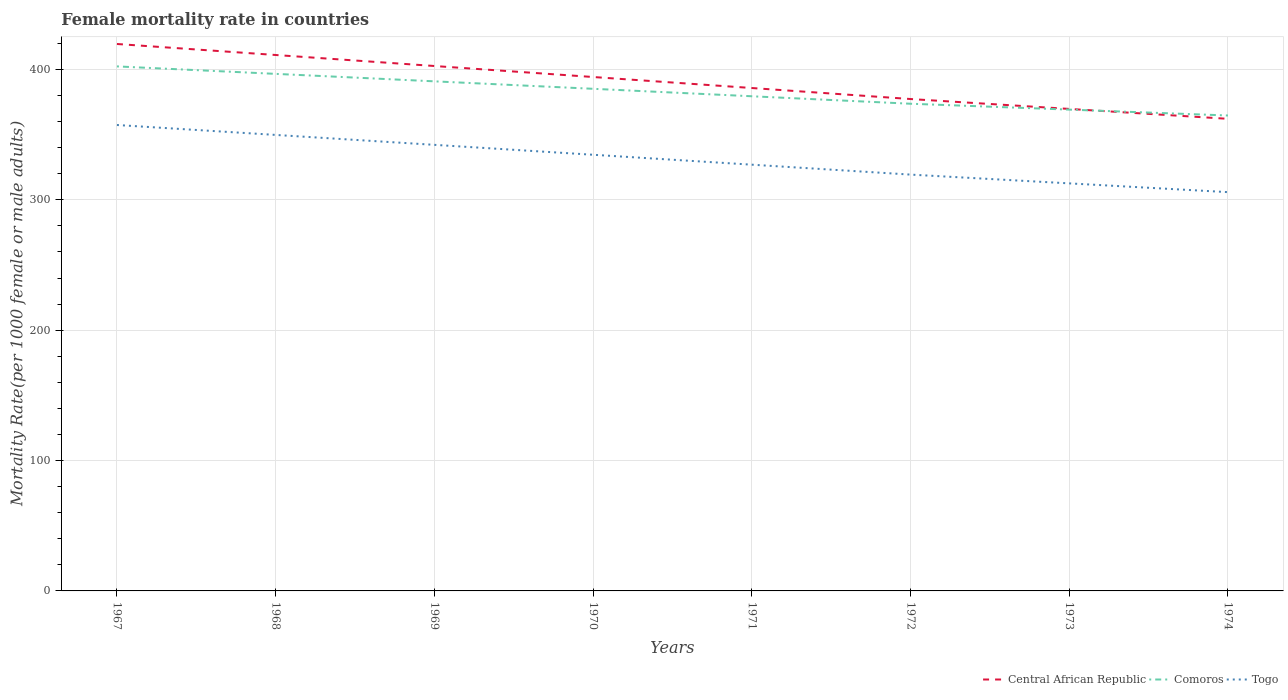How many different coloured lines are there?
Ensure brevity in your answer.  3. Does the line corresponding to Togo intersect with the line corresponding to Central African Republic?
Provide a short and direct response. No. Is the number of lines equal to the number of legend labels?
Your answer should be compact. Yes. Across all years, what is the maximum female mortality rate in Togo?
Make the answer very short. 305.9. In which year was the female mortality rate in Comoros maximum?
Your answer should be very brief. 1974. What is the total female mortality rate in Central African Republic in the graph?
Offer a terse response. 41.37. What is the difference between the highest and the second highest female mortality rate in Central African Republic?
Keep it short and to the point. 57.41. How many years are there in the graph?
Keep it short and to the point. 8. What is the difference between two consecutive major ticks on the Y-axis?
Make the answer very short. 100. Does the graph contain any zero values?
Give a very brief answer. No. Where does the legend appear in the graph?
Offer a very short reply. Bottom right. How many legend labels are there?
Ensure brevity in your answer.  3. What is the title of the graph?
Give a very brief answer. Female mortality rate in countries. Does "Tonga" appear as one of the legend labels in the graph?
Provide a succinct answer. No. What is the label or title of the X-axis?
Offer a very short reply. Years. What is the label or title of the Y-axis?
Your response must be concise. Mortality Rate(per 1000 female or male adults). What is the Mortality Rate(per 1000 female or male adults) of Central African Republic in 1967?
Your answer should be very brief. 419.55. What is the Mortality Rate(per 1000 female or male adults) of Comoros in 1967?
Ensure brevity in your answer.  402.36. What is the Mortality Rate(per 1000 female or male adults) of Togo in 1967?
Provide a short and direct response. 357.4. What is the Mortality Rate(per 1000 female or male adults) in Central African Republic in 1968?
Make the answer very short. 411.11. What is the Mortality Rate(per 1000 female or male adults) in Comoros in 1968?
Your answer should be compact. 396.63. What is the Mortality Rate(per 1000 female or male adults) of Togo in 1968?
Give a very brief answer. 349.79. What is the Mortality Rate(per 1000 female or male adults) in Central African Republic in 1969?
Give a very brief answer. 402.66. What is the Mortality Rate(per 1000 female or male adults) in Comoros in 1969?
Your response must be concise. 390.9. What is the Mortality Rate(per 1000 female or male adults) in Togo in 1969?
Your answer should be compact. 342.18. What is the Mortality Rate(per 1000 female or male adults) of Central African Republic in 1970?
Your answer should be compact. 394.22. What is the Mortality Rate(per 1000 female or male adults) of Comoros in 1970?
Your answer should be very brief. 385.17. What is the Mortality Rate(per 1000 female or male adults) in Togo in 1970?
Provide a succinct answer. 334.57. What is the Mortality Rate(per 1000 female or male adults) in Central African Republic in 1971?
Offer a very short reply. 385.77. What is the Mortality Rate(per 1000 female or male adults) of Comoros in 1971?
Give a very brief answer. 379.44. What is the Mortality Rate(per 1000 female or male adults) of Togo in 1971?
Make the answer very short. 326.97. What is the Mortality Rate(per 1000 female or male adults) of Central African Republic in 1972?
Offer a very short reply. 377.33. What is the Mortality Rate(per 1000 female or male adults) in Comoros in 1972?
Your answer should be compact. 373.72. What is the Mortality Rate(per 1000 female or male adults) of Togo in 1972?
Your response must be concise. 319.36. What is the Mortality Rate(per 1000 female or male adults) in Central African Republic in 1973?
Provide a short and direct response. 369.74. What is the Mortality Rate(per 1000 female or male adults) in Comoros in 1973?
Offer a very short reply. 369.21. What is the Mortality Rate(per 1000 female or male adults) in Togo in 1973?
Provide a succinct answer. 312.63. What is the Mortality Rate(per 1000 female or male adults) of Central African Republic in 1974?
Your answer should be very brief. 362.14. What is the Mortality Rate(per 1000 female or male adults) of Comoros in 1974?
Provide a succinct answer. 364.7. What is the Mortality Rate(per 1000 female or male adults) of Togo in 1974?
Provide a succinct answer. 305.9. Across all years, what is the maximum Mortality Rate(per 1000 female or male adults) in Central African Republic?
Make the answer very short. 419.55. Across all years, what is the maximum Mortality Rate(per 1000 female or male adults) of Comoros?
Keep it short and to the point. 402.36. Across all years, what is the maximum Mortality Rate(per 1000 female or male adults) of Togo?
Provide a succinct answer. 357.4. Across all years, what is the minimum Mortality Rate(per 1000 female or male adults) in Central African Republic?
Ensure brevity in your answer.  362.14. Across all years, what is the minimum Mortality Rate(per 1000 female or male adults) of Comoros?
Ensure brevity in your answer.  364.7. Across all years, what is the minimum Mortality Rate(per 1000 female or male adults) of Togo?
Ensure brevity in your answer.  305.9. What is the total Mortality Rate(per 1000 female or male adults) in Central African Republic in the graph?
Provide a short and direct response. 3122.51. What is the total Mortality Rate(per 1000 female or male adults) of Comoros in the graph?
Your response must be concise. 3062.12. What is the total Mortality Rate(per 1000 female or male adults) of Togo in the graph?
Make the answer very short. 2648.8. What is the difference between the Mortality Rate(per 1000 female or male adults) in Central African Republic in 1967 and that in 1968?
Offer a very short reply. 8.45. What is the difference between the Mortality Rate(per 1000 female or male adults) of Comoros in 1967 and that in 1968?
Your answer should be very brief. 5.73. What is the difference between the Mortality Rate(per 1000 female or male adults) in Togo in 1967 and that in 1968?
Offer a terse response. 7.61. What is the difference between the Mortality Rate(per 1000 female or male adults) of Central African Republic in 1967 and that in 1969?
Keep it short and to the point. 16.89. What is the difference between the Mortality Rate(per 1000 female or male adults) in Comoros in 1967 and that in 1969?
Keep it short and to the point. 11.46. What is the difference between the Mortality Rate(per 1000 female or male adults) in Togo in 1967 and that in 1969?
Provide a short and direct response. 15.22. What is the difference between the Mortality Rate(per 1000 female or male adults) of Central African Republic in 1967 and that in 1970?
Your answer should be compact. 25.33. What is the difference between the Mortality Rate(per 1000 female or male adults) in Comoros in 1967 and that in 1970?
Your answer should be compact. 17.18. What is the difference between the Mortality Rate(per 1000 female or male adults) in Togo in 1967 and that in 1970?
Your answer should be very brief. 22.83. What is the difference between the Mortality Rate(per 1000 female or male adults) in Central African Republic in 1967 and that in 1971?
Provide a succinct answer. 33.78. What is the difference between the Mortality Rate(per 1000 female or male adults) of Comoros in 1967 and that in 1971?
Provide a short and direct response. 22.91. What is the difference between the Mortality Rate(per 1000 female or male adults) in Togo in 1967 and that in 1971?
Keep it short and to the point. 30.43. What is the difference between the Mortality Rate(per 1000 female or male adults) in Central African Republic in 1967 and that in 1972?
Ensure brevity in your answer.  42.22. What is the difference between the Mortality Rate(per 1000 female or male adults) in Comoros in 1967 and that in 1972?
Your answer should be compact. 28.64. What is the difference between the Mortality Rate(per 1000 female or male adults) in Togo in 1967 and that in 1972?
Your response must be concise. 38.04. What is the difference between the Mortality Rate(per 1000 female or male adults) in Central African Republic in 1967 and that in 1973?
Provide a short and direct response. 49.82. What is the difference between the Mortality Rate(per 1000 female or male adults) in Comoros in 1967 and that in 1973?
Your answer should be compact. 33.15. What is the difference between the Mortality Rate(per 1000 female or male adults) of Togo in 1967 and that in 1973?
Your answer should be compact. 44.77. What is the difference between the Mortality Rate(per 1000 female or male adults) of Central African Republic in 1967 and that in 1974?
Provide a short and direct response. 57.41. What is the difference between the Mortality Rate(per 1000 female or male adults) of Comoros in 1967 and that in 1974?
Provide a succinct answer. 37.66. What is the difference between the Mortality Rate(per 1000 female or male adults) of Togo in 1967 and that in 1974?
Give a very brief answer. 51.5. What is the difference between the Mortality Rate(per 1000 female or male adults) in Central African Republic in 1968 and that in 1969?
Make the answer very short. 8.45. What is the difference between the Mortality Rate(per 1000 female or male adults) in Comoros in 1968 and that in 1969?
Make the answer very short. 5.73. What is the difference between the Mortality Rate(per 1000 female or male adults) of Togo in 1968 and that in 1969?
Provide a short and direct response. 7.61. What is the difference between the Mortality Rate(per 1000 female or male adults) of Central African Republic in 1968 and that in 1970?
Provide a short and direct response. 16.89. What is the difference between the Mortality Rate(per 1000 female or male adults) of Comoros in 1968 and that in 1970?
Keep it short and to the point. 11.46. What is the difference between the Mortality Rate(per 1000 female or male adults) in Togo in 1968 and that in 1970?
Provide a short and direct response. 15.22. What is the difference between the Mortality Rate(per 1000 female or male adults) of Central African Republic in 1968 and that in 1971?
Your response must be concise. 25.33. What is the difference between the Mortality Rate(per 1000 female or male adults) in Comoros in 1968 and that in 1971?
Your response must be concise. 17.18. What is the difference between the Mortality Rate(per 1000 female or male adults) of Togo in 1968 and that in 1971?
Give a very brief answer. 22.83. What is the difference between the Mortality Rate(per 1000 female or male adults) in Central African Republic in 1968 and that in 1972?
Provide a succinct answer. 33.78. What is the difference between the Mortality Rate(per 1000 female or male adults) in Comoros in 1968 and that in 1972?
Offer a terse response. 22.91. What is the difference between the Mortality Rate(per 1000 female or male adults) of Togo in 1968 and that in 1972?
Provide a succinct answer. 30.43. What is the difference between the Mortality Rate(per 1000 female or male adults) of Central African Republic in 1968 and that in 1973?
Ensure brevity in your answer.  41.37. What is the difference between the Mortality Rate(per 1000 female or male adults) in Comoros in 1968 and that in 1973?
Provide a succinct answer. 27.42. What is the difference between the Mortality Rate(per 1000 female or male adults) in Togo in 1968 and that in 1973?
Your answer should be very brief. 37.16. What is the difference between the Mortality Rate(per 1000 female or male adults) in Central African Republic in 1968 and that in 1974?
Your answer should be compact. 48.96. What is the difference between the Mortality Rate(per 1000 female or male adults) of Comoros in 1968 and that in 1974?
Keep it short and to the point. 31.93. What is the difference between the Mortality Rate(per 1000 female or male adults) of Togo in 1968 and that in 1974?
Provide a succinct answer. 43.89. What is the difference between the Mortality Rate(per 1000 female or male adults) of Central African Republic in 1969 and that in 1970?
Offer a terse response. 8.44. What is the difference between the Mortality Rate(per 1000 female or male adults) in Comoros in 1969 and that in 1970?
Offer a terse response. 5.73. What is the difference between the Mortality Rate(per 1000 female or male adults) in Togo in 1969 and that in 1970?
Provide a succinct answer. 7.61. What is the difference between the Mortality Rate(per 1000 female or male adults) of Central African Republic in 1969 and that in 1971?
Your answer should be compact. 16.89. What is the difference between the Mortality Rate(per 1000 female or male adults) of Comoros in 1969 and that in 1971?
Give a very brief answer. 11.46. What is the difference between the Mortality Rate(per 1000 female or male adults) in Togo in 1969 and that in 1971?
Keep it short and to the point. 15.22. What is the difference between the Mortality Rate(per 1000 female or male adults) of Central African Republic in 1969 and that in 1972?
Make the answer very short. 25.33. What is the difference between the Mortality Rate(per 1000 female or male adults) of Comoros in 1969 and that in 1972?
Your answer should be compact. 17.18. What is the difference between the Mortality Rate(per 1000 female or male adults) in Togo in 1969 and that in 1972?
Provide a succinct answer. 22.83. What is the difference between the Mortality Rate(per 1000 female or male adults) in Central African Republic in 1969 and that in 1973?
Your answer should be compact. 32.93. What is the difference between the Mortality Rate(per 1000 female or male adults) of Comoros in 1969 and that in 1973?
Keep it short and to the point. 21.7. What is the difference between the Mortality Rate(per 1000 female or male adults) of Togo in 1969 and that in 1973?
Your answer should be compact. 29.55. What is the difference between the Mortality Rate(per 1000 female or male adults) of Central African Republic in 1969 and that in 1974?
Your answer should be compact. 40.52. What is the difference between the Mortality Rate(per 1000 female or male adults) of Comoros in 1969 and that in 1974?
Keep it short and to the point. 26.2. What is the difference between the Mortality Rate(per 1000 female or male adults) in Togo in 1969 and that in 1974?
Your response must be concise. 36.28. What is the difference between the Mortality Rate(per 1000 female or male adults) in Central African Republic in 1970 and that in 1971?
Keep it short and to the point. 8.45. What is the difference between the Mortality Rate(per 1000 female or male adults) of Comoros in 1970 and that in 1971?
Keep it short and to the point. 5.73. What is the difference between the Mortality Rate(per 1000 female or male adults) of Togo in 1970 and that in 1971?
Make the answer very short. 7.61. What is the difference between the Mortality Rate(per 1000 female or male adults) in Central African Republic in 1970 and that in 1972?
Offer a terse response. 16.89. What is the difference between the Mortality Rate(per 1000 female or male adults) of Comoros in 1970 and that in 1972?
Ensure brevity in your answer.  11.46. What is the difference between the Mortality Rate(per 1000 female or male adults) in Togo in 1970 and that in 1972?
Provide a short and direct response. 15.22. What is the difference between the Mortality Rate(per 1000 female or male adults) in Central African Republic in 1970 and that in 1973?
Ensure brevity in your answer.  24.48. What is the difference between the Mortality Rate(per 1000 female or male adults) in Comoros in 1970 and that in 1973?
Your answer should be very brief. 15.97. What is the difference between the Mortality Rate(per 1000 female or male adults) in Togo in 1970 and that in 1973?
Your answer should be compact. 21.95. What is the difference between the Mortality Rate(per 1000 female or male adults) in Central African Republic in 1970 and that in 1974?
Your answer should be compact. 32.07. What is the difference between the Mortality Rate(per 1000 female or male adults) in Comoros in 1970 and that in 1974?
Your response must be concise. 20.48. What is the difference between the Mortality Rate(per 1000 female or male adults) of Togo in 1970 and that in 1974?
Your answer should be compact. 28.67. What is the difference between the Mortality Rate(per 1000 female or male adults) of Central African Republic in 1971 and that in 1972?
Your answer should be very brief. 8.45. What is the difference between the Mortality Rate(per 1000 female or male adults) in Comoros in 1971 and that in 1972?
Keep it short and to the point. 5.73. What is the difference between the Mortality Rate(per 1000 female or male adults) in Togo in 1971 and that in 1972?
Offer a very short reply. 7.61. What is the difference between the Mortality Rate(per 1000 female or male adults) in Central African Republic in 1971 and that in 1973?
Ensure brevity in your answer.  16.04. What is the difference between the Mortality Rate(per 1000 female or male adults) of Comoros in 1971 and that in 1973?
Ensure brevity in your answer.  10.24. What is the difference between the Mortality Rate(per 1000 female or male adults) of Togo in 1971 and that in 1973?
Offer a very short reply. 14.34. What is the difference between the Mortality Rate(per 1000 female or male adults) in Central African Republic in 1971 and that in 1974?
Keep it short and to the point. 23.63. What is the difference between the Mortality Rate(per 1000 female or male adults) of Comoros in 1971 and that in 1974?
Give a very brief answer. 14.75. What is the difference between the Mortality Rate(per 1000 female or male adults) in Togo in 1971 and that in 1974?
Offer a very short reply. 21.07. What is the difference between the Mortality Rate(per 1000 female or male adults) of Central African Republic in 1972 and that in 1973?
Your response must be concise. 7.59. What is the difference between the Mortality Rate(per 1000 female or male adults) in Comoros in 1972 and that in 1973?
Keep it short and to the point. 4.51. What is the difference between the Mortality Rate(per 1000 female or male adults) in Togo in 1972 and that in 1973?
Make the answer very short. 6.73. What is the difference between the Mortality Rate(per 1000 female or male adults) in Central African Republic in 1972 and that in 1974?
Provide a succinct answer. 15.18. What is the difference between the Mortality Rate(per 1000 female or male adults) of Comoros in 1972 and that in 1974?
Provide a succinct answer. 9.02. What is the difference between the Mortality Rate(per 1000 female or male adults) in Togo in 1972 and that in 1974?
Offer a terse response. 13.46. What is the difference between the Mortality Rate(per 1000 female or male adults) in Central African Republic in 1973 and that in 1974?
Your answer should be very brief. 7.59. What is the difference between the Mortality Rate(per 1000 female or male adults) of Comoros in 1973 and that in 1974?
Keep it short and to the point. 4.51. What is the difference between the Mortality Rate(per 1000 female or male adults) of Togo in 1973 and that in 1974?
Your answer should be compact. 6.73. What is the difference between the Mortality Rate(per 1000 female or male adults) in Central African Republic in 1967 and the Mortality Rate(per 1000 female or male adults) in Comoros in 1968?
Keep it short and to the point. 22.92. What is the difference between the Mortality Rate(per 1000 female or male adults) of Central African Republic in 1967 and the Mortality Rate(per 1000 female or male adults) of Togo in 1968?
Provide a succinct answer. 69.76. What is the difference between the Mortality Rate(per 1000 female or male adults) of Comoros in 1967 and the Mortality Rate(per 1000 female or male adults) of Togo in 1968?
Provide a short and direct response. 52.57. What is the difference between the Mortality Rate(per 1000 female or male adults) in Central African Republic in 1967 and the Mortality Rate(per 1000 female or male adults) in Comoros in 1969?
Ensure brevity in your answer.  28.65. What is the difference between the Mortality Rate(per 1000 female or male adults) in Central African Republic in 1967 and the Mortality Rate(per 1000 female or male adults) in Togo in 1969?
Give a very brief answer. 77.37. What is the difference between the Mortality Rate(per 1000 female or male adults) of Comoros in 1967 and the Mortality Rate(per 1000 female or male adults) of Togo in 1969?
Ensure brevity in your answer.  60.17. What is the difference between the Mortality Rate(per 1000 female or male adults) of Central African Republic in 1967 and the Mortality Rate(per 1000 female or male adults) of Comoros in 1970?
Provide a short and direct response. 34.38. What is the difference between the Mortality Rate(per 1000 female or male adults) in Central African Republic in 1967 and the Mortality Rate(per 1000 female or male adults) in Togo in 1970?
Make the answer very short. 84.98. What is the difference between the Mortality Rate(per 1000 female or male adults) of Comoros in 1967 and the Mortality Rate(per 1000 female or male adults) of Togo in 1970?
Your answer should be very brief. 67.78. What is the difference between the Mortality Rate(per 1000 female or male adults) in Central African Republic in 1967 and the Mortality Rate(per 1000 female or male adults) in Comoros in 1971?
Make the answer very short. 40.11. What is the difference between the Mortality Rate(per 1000 female or male adults) of Central African Republic in 1967 and the Mortality Rate(per 1000 female or male adults) of Togo in 1971?
Your answer should be compact. 92.58. What is the difference between the Mortality Rate(per 1000 female or male adults) in Comoros in 1967 and the Mortality Rate(per 1000 female or male adults) in Togo in 1971?
Provide a short and direct response. 75.39. What is the difference between the Mortality Rate(per 1000 female or male adults) in Central African Republic in 1967 and the Mortality Rate(per 1000 female or male adults) in Comoros in 1972?
Keep it short and to the point. 45.84. What is the difference between the Mortality Rate(per 1000 female or male adults) of Central African Republic in 1967 and the Mortality Rate(per 1000 female or male adults) of Togo in 1972?
Your answer should be compact. 100.19. What is the difference between the Mortality Rate(per 1000 female or male adults) of Comoros in 1967 and the Mortality Rate(per 1000 female or male adults) of Togo in 1972?
Your response must be concise. 83. What is the difference between the Mortality Rate(per 1000 female or male adults) in Central African Republic in 1967 and the Mortality Rate(per 1000 female or male adults) in Comoros in 1973?
Your answer should be very brief. 50.34. What is the difference between the Mortality Rate(per 1000 female or male adults) of Central African Republic in 1967 and the Mortality Rate(per 1000 female or male adults) of Togo in 1973?
Your response must be concise. 106.92. What is the difference between the Mortality Rate(per 1000 female or male adults) of Comoros in 1967 and the Mortality Rate(per 1000 female or male adults) of Togo in 1973?
Keep it short and to the point. 89.73. What is the difference between the Mortality Rate(per 1000 female or male adults) of Central African Republic in 1967 and the Mortality Rate(per 1000 female or male adults) of Comoros in 1974?
Keep it short and to the point. 54.85. What is the difference between the Mortality Rate(per 1000 female or male adults) of Central African Republic in 1967 and the Mortality Rate(per 1000 female or male adults) of Togo in 1974?
Offer a terse response. 113.65. What is the difference between the Mortality Rate(per 1000 female or male adults) of Comoros in 1967 and the Mortality Rate(per 1000 female or male adults) of Togo in 1974?
Provide a short and direct response. 96.46. What is the difference between the Mortality Rate(per 1000 female or male adults) of Central African Republic in 1968 and the Mortality Rate(per 1000 female or male adults) of Comoros in 1969?
Offer a terse response. 20.2. What is the difference between the Mortality Rate(per 1000 female or male adults) in Central African Republic in 1968 and the Mortality Rate(per 1000 female or male adults) in Togo in 1969?
Provide a succinct answer. 68.92. What is the difference between the Mortality Rate(per 1000 female or male adults) in Comoros in 1968 and the Mortality Rate(per 1000 female or male adults) in Togo in 1969?
Your answer should be compact. 54.45. What is the difference between the Mortality Rate(per 1000 female or male adults) of Central African Republic in 1968 and the Mortality Rate(per 1000 female or male adults) of Comoros in 1970?
Your answer should be very brief. 25.93. What is the difference between the Mortality Rate(per 1000 female or male adults) of Central African Republic in 1968 and the Mortality Rate(per 1000 female or male adults) of Togo in 1970?
Keep it short and to the point. 76.53. What is the difference between the Mortality Rate(per 1000 female or male adults) of Comoros in 1968 and the Mortality Rate(per 1000 female or male adults) of Togo in 1970?
Your answer should be very brief. 62.05. What is the difference between the Mortality Rate(per 1000 female or male adults) of Central African Republic in 1968 and the Mortality Rate(per 1000 female or male adults) of Comoros in 1971?
Your answer should be compact. 31.66. What is the difference between the Mortality Rate(per 1000 female or male adults) in Central African Republic in 1968 and the Mortality Rate(per 1000 female or male adults) in Togo in 1971?
Ensure brevity in your answer.  84.14. What is the difference between the Mortality Rate(per 1000 female or male adults) in Comoros in 1968 and the Mortality Rate(per 1000 female or male adults) in Togo in 1971?
Your answer should be very brief. 69.66. What is the difference between the Mortality Rate(per 1000 female or male adults) in Central African Republic in 1968 and the Mortality Rate(per 1000 female or male adults) in Comoros in 1972?
Keep it short and to the point. 37.39. What is the difference between the Mortality Rate(per 1000 female or male adults) in Central African Republic in 1968 and the Mortality Rate(per 1000 female or male adults) in Togo in 1972?
Your response must be concise. 91.75. What is the difference between the Mortality Rate(per 1000 female or male adults) of Comoros in 1968 and the Mortality Rate(per 1000 female or male adults) of Togo in 1972?
Offer a very short reply. 77.27. What is the difference between the Mortality Rate(per 1000 female or male adults) of Central African Republic in 1968 and the Mortality Rate(per 1000 female or male adults) of Comoros in 1973?
Provide a succinct answer. 41.9. What is the difference between the Mortality Rate(per 1000 female or male adults) of Central African Republic in 1968 and the Mortality Rate(per 1000 female or male adults) of Togo in 1973?
Make the answer very short. 98.48. What is the difference between the Mortality Rate(per 1000 female or male adults) in Central African Republic in 1968 and the Mortality Rate(per 1000 female or male adults) in Comoros in 1974?
Provide a succinct answer. 46.41. What is the difference between the Mortality Rate(per 1000 female or male adults) of Central African Republic in 1968 and the Mortality Rate(per 1000 female or male adults) of Togo in 1974?
Your answer should be compact. 105.2. What is the difference between the Mortality Rate(per 1000 female or male adults) of Comoros in 1968 and the Mortality Rate(per 1000 female or male adults) of Togo in 1974?
Your answer should be compact. 90.73. What is the difference between the Mortality Rate(per 1000 female or male adults) of Central African Republic in 1969 and the Mortality Rate(per 1000 female or male adults) of Comoros in 1970?
Provide a short and direct response. 17.49. What is the difference between the Mortality Rate(per 1000 female or male adults) in Central African Republic in 1969 and the Mortality Rate(per 1000 female or male adults) in Togo in 1970?
Give a very brief answer. 68.09. What is the difference between the Mortality Rate(per 1000 female or male adults) of Comoros in 1969 and the Mortality Rate(per 1000 female or male adults) of Togo in 1970?
Offer a terse response. 56.33. What is the difference between the Mortality Rate(per 1000 female or male adults) in Central African Republic in 1969 and the Mortality Rate(per 1000 female or male adults) in Comoros in 1971?
Offer a very short reply. 23.22. What is the difference between the Mortality Rate(per 1000 female or male adults) in Central African Republic in 1969 and the Mortality Rate(per 1000 female or male adults) in Togo in 1971?
Provide a succinct answer. 75.69. What is the difference between the Mortality Rate(per 1000 female or male adults) of Comoros in 1969 and the Mortality Rate(per 1000 female or male adults) of Togo in 1971?
Give a very brief answer. 63.94. What is the difference between the Mortality Rate(per 1000 female or male adults) in Central African Republic in 1969 and the Mortality Rate(per 1000 female or male adults) in Comoros in 1972?
Make the answer very short. 28.95. What is the difference between the Mortality Rate(per 1000 female or male adults) of Central African Republic in 1969 and the Mortality Rate(per 1000 female or male adults) of Togo in 1972?
Your answer should be very brief. 83.3. What is the difference between the Mortality Rate(per 1000 female or male adults) of Comoros in 1969 and the Mortality Rate(per 1000 female or male adults) of Togo in 1972?
Offer a very short reply. 71.54. What is the difference between the Mortality Rate(per 1000 female or male adults) of Central African Republic in 1969 and the Mortality Rate(per 1000 female or male adults) of Comoros in 1973?
Give a very brief answer. 33.45. What is the difference between the Mortality Rate(per 1000 female or male adults) of Central African Republic in 1969 and the Mortality Rate(per 1000 female or male adults) of Togo in 1973?
Ensure brevity in your answer.  90.03. What is the difference between the Mortality Rate(per 1000 female or male adults) of Comoros in 1969 and the Mortality Rate(per 1000 female or male adults) of Togo in 1973?
Provide a short and direct response. 78.27. What is the difference between the Mortality Rate(per 1000 female or male adults) of Central African Republic in 1969 and the Mortality Rate(per 1000 female or male adults) of Comoros in 1974?
Ensure brevity in your answer.  37.97. What is the difference between the Mortality Rate(per 1000 female or male adults) of Central African Republic in 1969 and the Mortality Rate(per 1000 female or male adults) of Togo in 1974?
Your answer should be compact. 96.76. What is the difference between the Mortality Rate(per 1000 female or male adults) of Comoros in 1969 and the Mortality Rate(per 1000 female or male adults) of Togo in 1974?
Give a very brief answer. 85. What is the difference between the Mortality Rate(per 1000 female or male adults) in Central African Republic in 1970 and the Mortality Rate(per 1000 female or male adults) in Comoros in 1971?
Your response must be concise. 14.77. What is the difference between the Mortality Rate(per 1000 female or male adults) of Central African Republic in 1970 and the Mortality Rate(per 1000 female or male adults) of Togo in 1971?
Your response must be concise. 67.25. What is the difference between the Mortality Rate(per 1000 female or male adults) in Comoros in 1970 and the Mortality Rate(per 1000 female or male adults) in Togo in 1971?
Offer a very short reply. 58.21. What is the difference between the Mortality Rate(per 1000 female or male adults) of Central African Republic in 1970 and the Mortality Rate(per 1000 female or male adults) of Comoros in 1972?
Provide a short and direct response. 20.5. What is the difference between the Mortality Rate(per 1000 female or male adults) in Central African Republic in 1970 and the Mortality Rate(per 1000 female or male adults) in Togo in 1972?
Your answer should be very brief. 74.86. What is the difference between the Mortality Rate(per 1000 female or male adults) of Comoros in 1970 and the Mortality Rate(per 1000 female or male adults) of Togo in 1972?
Your answer should be compact. 65.82. What is the difference between the Mortality Rate(per 1000 female or male adults) in Central African Republic in 1970 and the Mortality Rate(per 1000 female or male adults) in Comoros in 1973?
Your answer should be compact. 25.01. What is the difference between the Mortality Rate(per 1000 female or male adults) of Central African Republic in 1970 and the Mortality Rate(per 1000 female or male adults) of Togo in 1973?
Keep it short and to the point. 81.59. What is the difference between the Mortality Rate(per 1000 female or male adults) of Comoros in 1970 and the Mortality Rate(per 1000 female or male adults) of Togo in 1973?
Your answer should be compact. 72.54. What is the difference between the Mortality Rate(per 1000 female or male adults) in Central African Republic in 1970 and the Mortality Rate(per 1000 female or male adults) in Comoros in 1974?
Make the answer very short. 29.52. What is the difference between the Mortality Rate(per 1000 female or male adults) of Central African Republic in 1970 and the Mortality Rate(per 1000 female or male adults) of Togo in 1974?
Provide a succinct answer. 88.32. What is the difference between the Mortality Rate(per 1000 female or male adults) of Comoros in 1970 and the Mortality Rate(per 1000 female or male adults) of Togo in 1974?
Provide a short and direct response. 79.27. What is the difference between the Mortality Rate(per 1000 female or male adults) in Central African Republic in 1971 and the Mortality Rate(per 1000 female or male adults) in Comoros in 1972?
Offer a terse response. 12.06. What is the difference between the Mortality Rate(per 1000 female or male adults) of Central African Republic in 1971 and the Mortality Rate(per 1000 female or male adults) of Togo in 1972?
Your answer should be compact. 66.42. What is the difference between the Mortality Rate(per 1000 female or male adults) of Comoros in 1971 and the Mortality Rate(per 1000 female or male adults) of Togo in 1972?
Provide a short and direct response. 60.09. What is the difference between the Mortality Rate(per 1000 female or male adults) in Central African Republic in 1971 and the Mortality Rate(per 1000 female or male adults) in Comoros in 1973?
Ensure brevity in your answer.  16.57. What is the difference between the Mortality Rate(per 1000 female or male adults) of Central African Republic in 1971 and the Mortality Rate(per 1000 female or male adults) of Togo in 1973?
Your response must be concise. 73.14. What is the difference between the Mortality Rate(per 1000 female or male adults) in Comoros in 1971 and the Mortality Rate(per 1000 female or male adults) in Togo in 1973?
Your response must be concise. 66.81. What is the difference between the Mortality Rate(per 1000 female or male adults) in Central African Republic in 1971 and the Mortality Rate(per 1000 female or male adults) in Comoros in 1974?
Provide a short and direct response. 21.08. What is the difference between the Mortality Rate(per 1000 female or male adults) of Central African Republic in 1971 and the Mortality Rate(per 1000 female or male adults) of Togo in 1974?
Your response must be concise. 79.87. What is the difference between the Mortality Rate(per 1000 female or male adults) in Comoros in 1971 and the Mortality Rate(per 1000 female or male adults) in Togo in 1974?
Offer a terse response. 73.54. What is the difference between the Mortality Rate(per 1000 female or male adults) of Central African Republic in 1972 and the Mortality Rate(per 1000 female or male adults) of Comoros in 1973?
Offer a very short reply. 8.12. What is the difference between the Mortality Rate(per 1000 female or male adults) in Central African Republic in 1972 and the Mortality Rate(per 1000 female or male adults) in Togo in 1973?
Provide a short and direct response. 64.7. What is the difference between the Mortality Rate(per 1000 female or male adults) of Comoros in 1972 and the Mortality Rate(per 1000 female or male adults) of Togo in 1973?
Offer a terse response. 61.09. What is the difference between the Mortality Rate(per 1000 female or male adults) of Central African Republic in 1972 and the Mortality Rate(per 1000 female or male adults) of Comoros in 1974?
Your response must be concise. 12.63. What is the difference between the Mortality Rate(per 1000 female or male adults) in Central African Republic in 1972 and the Mortality Rate(per 1000 female or male adults) in Togo in 1974?
Keep it short and to the point. 71.43. What is the difference between the Mortality Rate(per 1000 female or male adults) in Comoros in 1972 and the Mortality Rate(per 1000 female or male adults) in Togo in 1974?
Provide a succinct answer. 67.81. What is the difference between the Mortality Rate(per 1000 female or male adults) of Central African Republic in 1973 and the Mortality Rate(per 1000 female or male adults) of Comoros in 1974?
Ensure brevity in your answer.  5.04. What is the difference between the Mortality Rate(per 1000 female or male adults) of Central African Republic in 1973 and the Mortality Rate(per 1000 female or male adults) of Togo in 1974?
Give a very brief answer. 63.83. What is the difference between the Mortality Rate(per 1000 female or male adults) of Comoros in 1973 and the Mortality Rate(per 1000 female or male adults) of Togo in 1974?
Make the answer very short. 63.3. What is the average Mortality Rate(per 1000 female or male adults) of Central African Republic per year?
Offer a terse response. 390.31. What is the average Mortality Rate(per 1000 female or male adults) of Comoros per year?
Your answer should be very brief. 382.77. What is the average Mortality Rate(per 1000 female or male adults) of Togo per year?
Your answer should be compact. 331.1. In the year 1967, what is the difference between the Mortality Rate(per 1000 female or male adults) of Central African Republic and Mortality Rate(per 1000 female or male adults) of Comoros?
Your response must be concise. 17.19. In the year 1967, what is the difference between the Mortality Rate(per 1000 female or male adults) of Central African Republic and Mortality Rate(per 1000 female or male adults) of Togo?
Ensure brevity in your answer.  62.15. In the year 1967, what is the difference between the Mortality Rate(per 1000 female or male adults) of Comoros and Mortality Rate(per 1000 female or male adults) of Togo?
Offer a terse response. 44.96. In the year 1968, what is the difference between the Mortality Rate(per 1000 female or male adults) of Central African Republic and Mortality Rate(per 1000 female or male adults) of Comoros?
Provide a succinct answer. 14.48. In the year 1968, what is the difference between the Mortality Rate(per 1000 female or male adults) of Central African Republic and Mortality Rate(per 1000 female or male adults) of Togo?
Keep it short and to the point. 61.31. In the year 1968, what is the difference between the Mortality Rate(per 1000 female or male adults) in Comoros and Mortality Rate(per 1000 female or male adults) in Togo?
Provide a short and direct response. 46.84. In the year 1969, what is the difference between the Mortality Rate(per 1000 female or male adults) of Central African Republic and Mortality Rate(per 1000 female or male adults) of Comoros?
Provide a short and direct response. 11.76. In the year 1969, what is the difference between the Mortality Rate(per 1000 female or male adults) of Central African Republic and Mortality Rate(per 1000 female or male adults) of Togo?
Provide a succinct answer. 60.48. In the year 1969, what is the difference between the Mortality Rate(per 1000 female or male adults) in Comoros and Mortality Rate(per 1000 female or male adults) in Togo?
Your answer should be very brief. 48.72. In the year 1970, what is the difference between the Mortality Rate(per 1000 female or male adults) of Central African Republic and Mortality Rate(per 1000 female or male adults) of Comoros?
Keep it short and to the point. 9.04. In the year 1970, what is the difference between the Mortality Rate(per 1000 female or male adults) of Central African Republic and Mortality Rate(per 1000 female or male adults) of Togo?
Keep it short and to the point. 59.64. In the year 1970, what is the difference between the Mortality Rate(per 1000 female or male adults) of Comoros and Mortality Rate(per 1000 female or male adults) of Togo?
Provide a short and direct response. 50.6. In the year 1971, what is the difference between the Mortality Rate(per 1000 female or male adults) of Central African Republic and Mortality Rate(per 1000 female or male adults) of Comoros?
Provide a short and direct response. 6.33. In the year 1971, what is the difference between the Mortality Rate(per 1000 female or male adults) of Central African Republic and Mortality Rate(per 1000 female or male adults) of Togo?
Give a very brief answer. 58.81. In the year 1971, what is the difference between the Mortality Rate(per 1000 female or male adults) of Comoros and Mortality Rate(per 1000 female or male adults) of Togo?
Provide a succinct answer. 52.48. In the year 1972, what is the difference between the Mortality Rate(per 1000 female or male adults) of Central African Republic and Mortality Rate(per 1000 female or male adults) of Comoros?
Give a very brief answer. 3.61. In the year 1972, what is the difference between the Mortality Rate(per 1000 female or male adults) of Central African Republic and Mortality Rate(per 1000 female or male adults) of Togo?
Keep it short and to the point. 57.97. In the year 1972, what is the difference between the Mortality Rate(per 1000 female or male adults) in Comoros and Mortality Rate(per 1000 female or male adults) in Togo?
Give a very brief answer. 54.36. In the year 1973, what is the difference between the Mortality Rate(per 1000 female or male adults) in Central African Republic and Mortality Rate(per 1000 female or male adults) in Comoros?
Give a very brief answer. 0.53. In the year 1973, what is the difference between the Mortality Rate(per 1000 female or male adults) of Central African Republic and Mortality Rate(per 1000 female or male adults) of Togo?
Your answer should be compact. 57.11. In the year 1973, what is the difference between the Mortality Rate(per 1000 female or male adults) of Comoros and Mortality Rate(per 1000 female or male adults) of Togo?
Your answer should be compact. 56.58. In the year 1974, what is the difference between the Mortality Rate(per 1000 female or male adults) of Central African Republic and Mortality Rate(per 1000 female or male adults) of Comoros?
Provide a short and direct response. -2.55. In the year 1974, what is the difference between the Mortality Rate(per 1000 female or male adults) in Central African Republic and Mortality Rate(per 1000 female or male adults) in Togo?
Give a very brief answer. 56.24. In the year 1974, what is the difference between the Mortality Rate(per 1000 female or male adults) of Comoros and Mortality Rate(per 1000 female or male adults) of Togo?
Make the answer very short. 58.8. What is the ratio of the Mortality Rate(per 1000 female or male adults) of Central African Republic in 1967 to that in 1968?
Keep it short and to the point. 1.02. What is the ratio of the Mortality Rate(per 1000 female or male adults) of Comoros in 1967 to that in 1968?
Make the answer very short. 1.01. What is the ratio of the Mortality Rate(per 1000 female or male adults) of Togo in 1967 to that in 1968?
Your answer should be compact. 1.02. What is the ratio of the Mortality Rate(per 1000 female or male adults) of Central African Republic in 1967 to that in 1969?
Make the answer very short. 1.04. What is the ratio of the Mortality Rate(per 1000 female or male adults) in Comoros in 1967 to that in 1969?
Your response must be concise. 1.03. What is the ratio of the Mortality Rate(per 1000 female or male adults) in Togo in 1967 to that in 1969?
Provide a short and direct response. 1.04. What is the ratio of the Mortality Rate(per 1000 female or male adults) of Central African Republic in 1967 to that in 1970?
Keep it short and to the point. 1.06. What is the ratio of the Mortality Rate(per 1000 female or male adults) of Comoros in 1967 to that in 1970?
Your response must be concise. 1.04. What is the ratio of the Mortality Rate(per 1000 female or male adults) of Togo in 1967 to that in 1970?
Make the answer very short. 1.07. What is the ratio of the Mortality Rate(per 1000 female or male adults) of Central African Republic in 1967 to that in 1971?
Keep it short and to the point. 1.09. What is the ratio of the Mortality Rate(per 1000 female or male adults) in Comoros in 1967 to that in 1971?
Offer a terse response. 1.06. What is the ratio of the Mortality Rate(per 1000 female or male adults) in Togo in 1967 to that in 1971?
Keep it short and to the point. 1.09. What is the ratio of the Mortality Rate(per 1000 female or male adults) of Central African Republic in 1967 to that in 1972?
Your answer should be very brief. 1.11. What is the ratio of the Mortality Rate(per 1000 female or male adults) of Comoros in 1967 to that in 1972?
Provide a short and direct response. 1.08. What is the ratio of the Mortality Rate(per 1000 female or male adults) in Togo in 1967 to that in 1972?
Keep it short and to the point. 1.12. What is the ratio of the Mortality Rate(per 1000 female or male adults) of Central African Republic in 1967 to that in 1973?
Keep it short and to the point. 1.13. What is the ratio of the Mortality Rate(per 1000 female or male adults) in Comoros in 1967 to that in 1973?
Ensure brevity in your answer.  1.09. What is the ratio of the Mortality Rate(per 1000 female or male adults) in Togo in 1967 to that in 1973?
Offer a very short reply. 1.14. What is the ratio of the Mortality Rate(per 1000 female or male adults) in Central African Republic in 1967 to that in 1974?
Offer a terse response. 1.16. What is the ratio of the Mortality Rate(per 1000 female or male adults) in Comoros in 1967 to that in 1974?
Give a very brief answer. 1.1. What is the ratio of the Mortality Rate(per 1000 female or male adults) of Togo in 1967 to that in 1974?
Your answer should be very brief. 1.17. What is the ratio of the Mortality Rate(per 1000 female or male adults) of Central African Republic in 1968 to that in 1969?
Your response must be concise. 1.02. What is the ratio of the Mortality Rate(per 1000 female or male adults) of Comoros in 1968 to that in 1969?
Provide a succinct answer. 1.01. What is the ratio of the Mortality Rate(per 1000 female or male adults) in Togo in 1968 to that in 1969?
Your answer should be compact. 1.02. What is the ratio of the Mortality Rate(per 1000 female or male adults) in Central African Republic in 1968 to that in 1970?
Give a very brief answer. 1.04. What is the ratio of the Mortality Rate(per 1000 female or male adults) in Comoros in 1968 to that in 1970?
Offer a terse response. 1.03. What is the ratio of the Mortality Rate(per 1000 female or male adults) of Togo in 1968 to that in 1970?
Ensure brevity in your answer.  1.05. What is the ratio of the Mortality Rate(per 1000 female or male adults) of Central African Republic in 1968 to that in 1971?
Your response must be concise. 1.07. What is the ratio of the Mortality Rate(per 1000 female or male adults) in Comoros in 1968 to that in 1971?
Keep it short and to the point. 1.05. What is the ratio of the Mortality Rate(per 1000 female or male adults) in Togo in 1968 to that in 1971?
Offer a very short reply. 1.07. What is the ratio of the Mortality Rate(per 1000 female or male adults) of Central African Republic in 1968 to that in 1972?
Your response must be concise. 1.09. What is the ratio of the Mortality Rate(per 1000 female or male adults) in Comoros in 1968 to that in 1972?
Give a very brief answer. 1.06. What is the ratio of the Mortality Rate(per 1000 female or male adults) of Togo in 1968 to that in 1972?
Provide a short and direct response. 1.1. What is the ratio of the Mortality Rate(per 1000 female or male adults) of Central African Republic in 1968 to that in 1973?
Make the answer very short. 1.11. What is the ratio of the Mortality Rate(per 1000 female or male adults) in Comoros in 1968 to that in 1973?
Ensure brevity in your answer.  1.07. What is the ratio of the Mortality Rate(per 1000 female or male adults) of Togo in 1968 to that in 1973?
Offer a very short reply. 1.12. What is the ratio of the Mortality Rate(per 1000 female or male adults) in Central African Republic in 1968 to that in 1974?
Offer a terse response. 1.14. What is the ratio of the Mortality Rate(per 1000 female or male adults) in Comoros in 1968 to that in 1974?
Your answer should be very brief. 1.09. What is the ratio of the Mortality Rate(per 1000 female or male adults) in Togo in 1968 to that in 1974?
Ensure brevity in your answer.  1.14. What is the ratio of the Mortality Rate(per 1000 female or male adults) in Central African Republic in 1969 to that in 1970?
Provide a succinct answer. 1.02. What is the ratio of the Mortality Rate(per 1000 female or male adults) of Comoros in 1969 to that in 1970?
Offer a very short reply. 1.01. What is the ratio of the Mortality Rate(per 1000 female or male adults) in Togo in 1969 to that in 1970?
Give a very brief answer. 1.02. What is the ratio of the Mortality Rate(per 1000 female or male adults) of Central African Republic in 1969 to that in 1971?
Your answer should be compact. 1.04. What is the ratio of the Mortality Rate(per 1000 female or male adults) in Comoros in 1969 to that in 1971?
Your answer should be compact. 1.03. What is the ratio of the Mortality Rate(per 1000 female or male adults) of Togo in 1969 to that in 1971?
Your answer should be very brief. 1.05. What is the ratio of the Mortality Rate(per 1000 female or male adults) of Central African Republic in 1969 to that in 1972?
Your response must be concise. 1.07. What is the ratio of the Mortality Rate(per 1000 female or male adults) of Comoros in 1969 to that in 1972?
Give a very brief answer. 1.05. What is the ratio of the Mortality Rate(per 1000 female or male adults) in Togo in 1969 to that in 1972?
Ensure brevity in your answer.  1.07. What is the ratio of the Mortality Rate(per 1000 female or male adults) of Central African Republic in 1969 to that in 1973?
Make the answer very short. 1.09. What is the ratio of the Mortality Rate(per 1000 female or male adults) in Comoros in 1969 to that in 1973?
Give a very brief answer. 1.06. What is the ratio of the Mortality Rate(per 1000 female or male adults) in Togo in 1969 to that in 1973?
Ensure brevity in your answer.  1.09. What is the ratio of the Mortality Rate(per 1000 female or male adults) of Central African Republic in 1969 to that in 1974?
Make the answer very short. 1.11. What is the ratio of the Mortality Rate(per 1000 female or male adults) in Comoros in 1969 to that in 1974?
Provide a short and direct response. 1.07. What is the ratio of the Mortality Rate(per 1000 female or male adults) of Togo in 1969 to that in 1974?
Give a very brief answer. 1.12. What is the ratio of the Mortality Rate(per 1000 female or male adults) of Central African Republic in 1970 to that in 1971?
Make the answer very short. 1.02. What is the ratio of the Mortality Rate(per 1000 female or male adults) of Comoros in 1970 to that in 1971?
Your response must be concise. 1.02. What is the ratio of the Mortality Rate(per 1000 female or male adults) of Togo in 1970 to that in 1971?
Provide a short and direct response. 1.02. What is the ratio of the Mortality Rate(per 1000 female or male adults) of Central African Republic in 1970 to that in 1972?
Make the answer very short. 1.04. What is the ratio of the Mortality Rate(per 1000 female or male adults) in Comoros in 1970 to that in 1972?
Your answer should be very brief. 1.03. What is the ratio of the Mortality Rate(per 1000 female or male adults) in Togo in 1970 to that in 1972?
Offer a very short reply. 1.05. What is the ratio of the Mortality Rate(per 1000 female or male adults) in Central African Republic in 1970 to that in 1973?
Keep it short and to the point. 1.07. What is the ratio of the Mortality Rate(per 1000 female or male adults) of Comoros in 1970 to that in 1973?
Keep it short and to the point. 1.04. What is the ratio of the Mortality Rate(per 1000 female or male adults) in Togo in 1970 to that in 1973?
Provide a succinct answer. 1.07. What is the ratio of the Mortality Rate(per 1000 female or male adults) of Central African Republic in 1970 to that in 1974?
Provide a succinct answer. 1.09. What is the ratio of the Mortality Rate(per 1000 female or male adults) in Comoros in 1970 to that in 1974?
Make the answer very short. 1.06. What is the ratio of the Mortality Rate(per 1000 female or male adults) in Togo in 1970 to that in 1974?
Offer a very short reply. 1.09. What is the ratio of the Mortality Rate(per 1000 female or male adults) in Central African Republic in 1971 to that in 1972?
Keep it short and to the point. 1.02. What is the ratio of the Mortality Rate(per 1000 female or male adults) in Comoros in 1971 to that in 1972?
Your answer should be very brief. 1.02. What is the ratio of the Mortality Rate(per 1000 female or male adults) in Togo in 1971 to that in 1972?
Your answer should be very brief. 1.02. What is the ratio of the Mortality Rate(per 1000 female or male adults) in Central African Republic in 1971 to that in 1973?
Your answer should be very brief. 1.04. What is the ratio of the Mortality Rate(per 1000 female or male adults) of Comoros in 1971 to that in 1973?
Keep it short and to the point. 1.03. What is the ratio of the Mortality Rate(per 1000 female or male adults) of Togo in 1971 to that in 1973?
Ensure brevity in your answer.  1.05. What is the ratio of the Mortality Rate(per 1000 female or male adults) of Central African Republic in 1971 to that in 1974?
Your response must be concise. 1.07. What is the ratio of the Mortality Rate(per 1000 female or male adults) in Comoros in 1971 to that in 1974?
Provide a short and direct response. 1.04. What is the ratio of the Mortality Rate(per 1000 female or male adults) of Togo in 1971 to that in 1974?
Provide a short and direct response. 1.07. What is the ratio of the Mortality Rate(per 1000 female or male adults) of Central African Republic in 1972 to that in 1973?
Make the answer very short. 1.02. What is the ratio of the Mortality Rate(per 1000 female or male adults) of Comoros in 1972 to that in 1973?
Ensure brevity in your answer.  1.01. What is the ratio of the Mortality Rate(per 1000 female or male adults) of Togo in 1972 to that in 1973?
Offer a very short reply. 1.02. What is the ratio of the Mortality Rate(per 1000 female or male adults) in Central African Republic in 1972 to that in 1974?
Provide a short and direct response. 1.04. What is the ratio of the Mortality Rate(per 1000 female or male adults) in Comoros in 1972 to that in 1974?
Offer a terse response. 1.02. What is the ratio of the Mortality Rate(per 1000 female or male adults) of Togo in 1972 to that in 1974?
Your answer should be compact. 1.04. What is the ratio of the Mortality Rate(per 1000 female or male adults) of Central African Republic in 1973 to that in 1974?
Give a very brief answer. 1.02. What is the ratio of the Mortality Rate(per 1000 female or male adults) of Comoros in 1973 to that in 1974?
Offer a terse response. 1.01. What is the ratio of the Mortality Rate(per 1000 female or male adults) in Togo in 1973 to that in 1974?
Make the answer very short. 1.02. What is the difference between the highest and the second highest Mortality Rate(per 1000 female or male adults) of Central African Republic?
Offer a terse response. 8.45. What is the difference between the highest and the second highest Mortality Rate(per 1000 female or male adults) in Comoros?
Your response must be concise. 5.73. What is the difference between the highest and the second highest Mortality Rate(per 1000 female or male adults) of Togo?
Your answer should be compact. 7.61. What is the difference between the highest and the lowest Mortality Rate(per 1000 female or male adults) in Central African Republic?
Offer a very short reply. 57.41. What is the difference between the highest and the lowest Mortality Rate(per 1000 female or male adults) in Comoros?
Offer a very short reply. 37.66. What is the difference between the highest and the lowest Mortality Rate(per 1000 female or male adults) in Togo?
Provide a short and direct response. 51.5. 